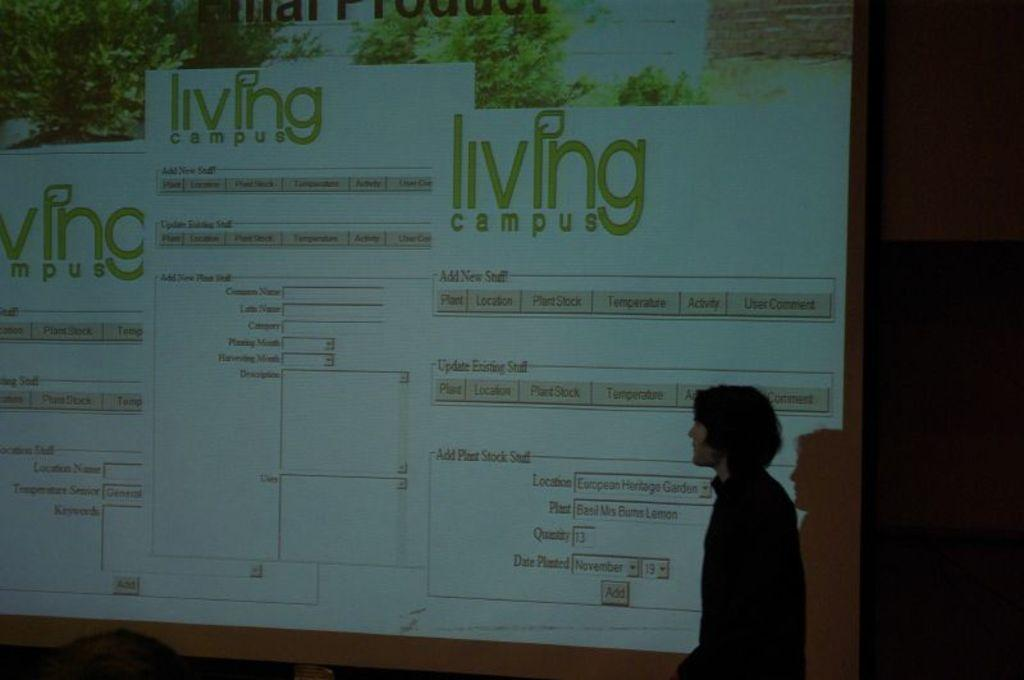<image>
Create a compact narrative representing the image presented. A man standing in front of a movie screen showing the words living campus. 